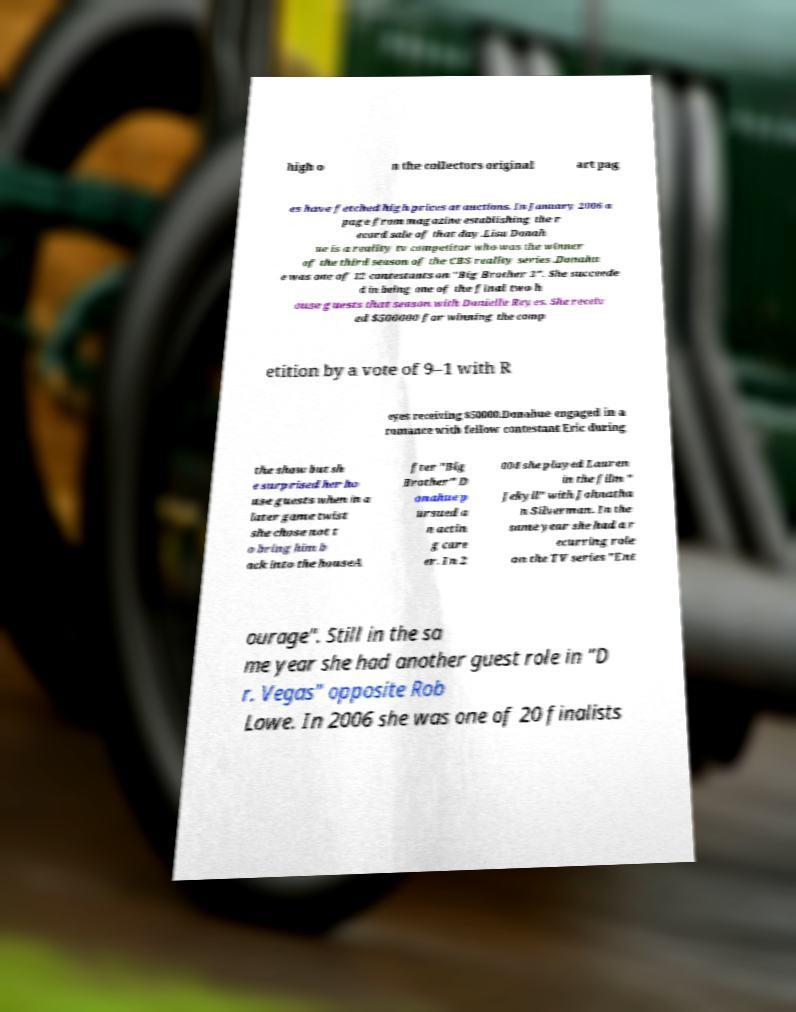I need the written content from this picture converted into text. Can you do that? high o n the collectors original art pag es have fetched high prices at auctions. In January 2006 a page from magazine establishing the r ecord sale of that day.Lisa Donah ue is a reality tv competitor who was the winner of the third season of the CBS reality series .Donahu e was one of 12 contestants on "Big Brother 3". She succeede d in being one of the final two h ouse guests that season with Danielle Reyes. She receiv ed $500000 for winning the comp etition by a vote of 9–1 with R eyes receiving $50000.Donahue engaged in a romance with fellow contestant Eric during the show but sh e surprised her ho use guests when in a later game twist she chose not t o bring him b ack into the houseA fter "Big Brother" D onahue p ursued a n actin g care er. In 2 004 she played Lauren in the film " Jekyll" with Johnatha n Silverman. In the same year she had a r ecurring role on the TV series "Ent ourage". Still in the sa me year she had another guest role in "D r. Vegas" opposite Rob Lowe. In 2006 she was one of 20 finalists 